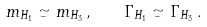Convert formula to latex. <formula><loc_0><loc_0><loc_500><loc_500>m _ { H _ { 1 } } \simeq m _ { H _ { 3 } } \, , \quad \Gamma _ { H _ { 1 } } \simeq \Gamma _ { H _ { 3 } } \, .</formula> 